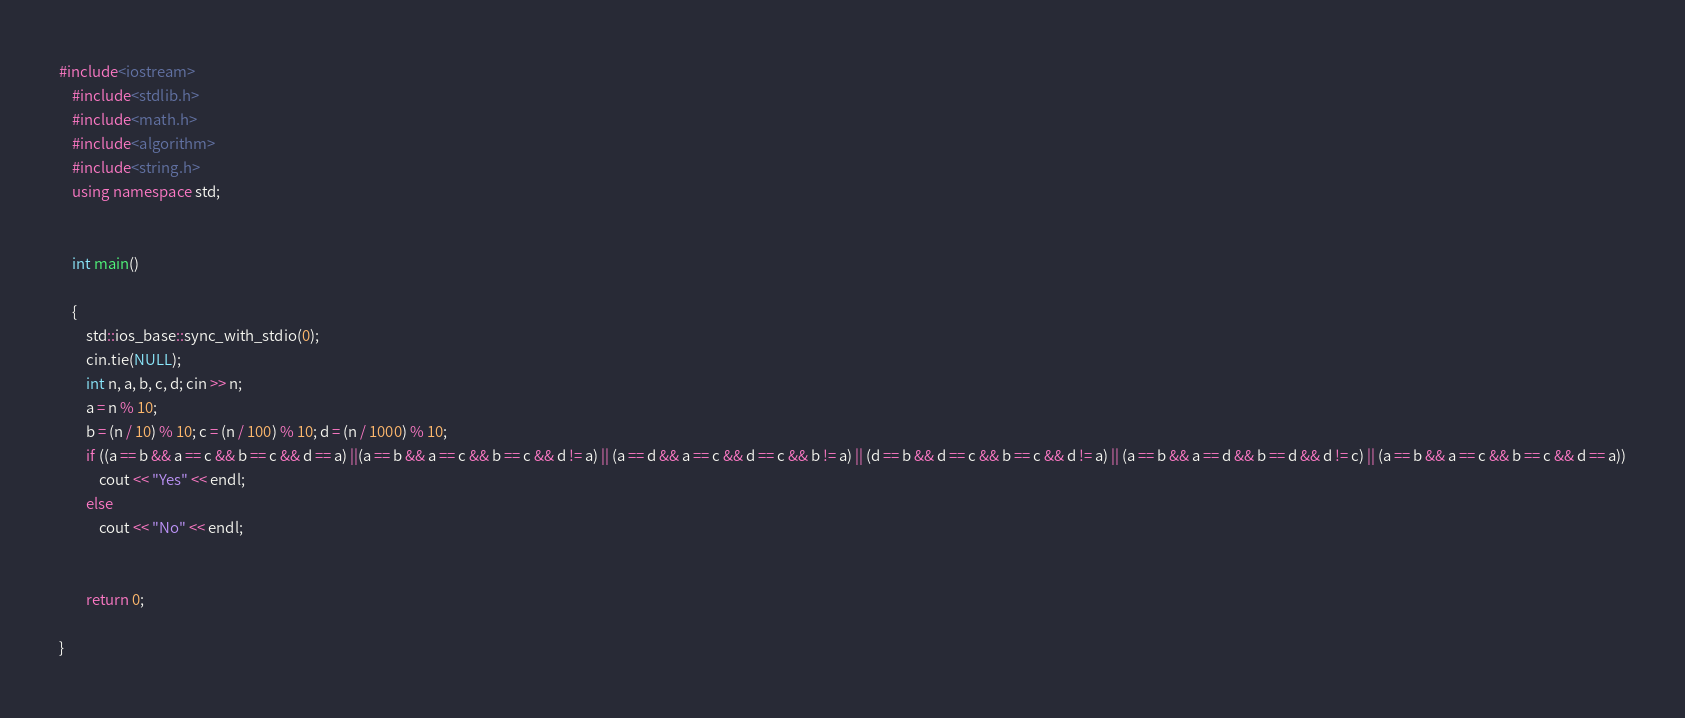<code> <loc_0><loc_0><loc_500><loc_500><_C++_>#include<iostream>
	#include<stdlib.h>
	#include<math.h>
	#include<algorithm>
	#include<string.h>
	using namespace std;


	int main()

	{
		std::ios_base::sync_with_stdio(0);
		cin.tie(NULL);
		int n, a, b, c, d; cin >> n;
		a = n % 10;
		b = (n / 10) % 10; c = (n / 100) % 10; d = (n / 1000) % 10;
		if ((a == b && a == c && b == c && d == a) ||(a == b && a == c && b == c && d != a) || (a == d && a == c && d == c && b != a) || (d == b && d == c && b == c && d != a) || (a == b && a == d && b == d && d != c) || (a == b && a == c && b == c && d == a))
			cout << "Yes" << endl;
		else
			cout << "No" << endl;

		
		return 0;
	
}</code> 